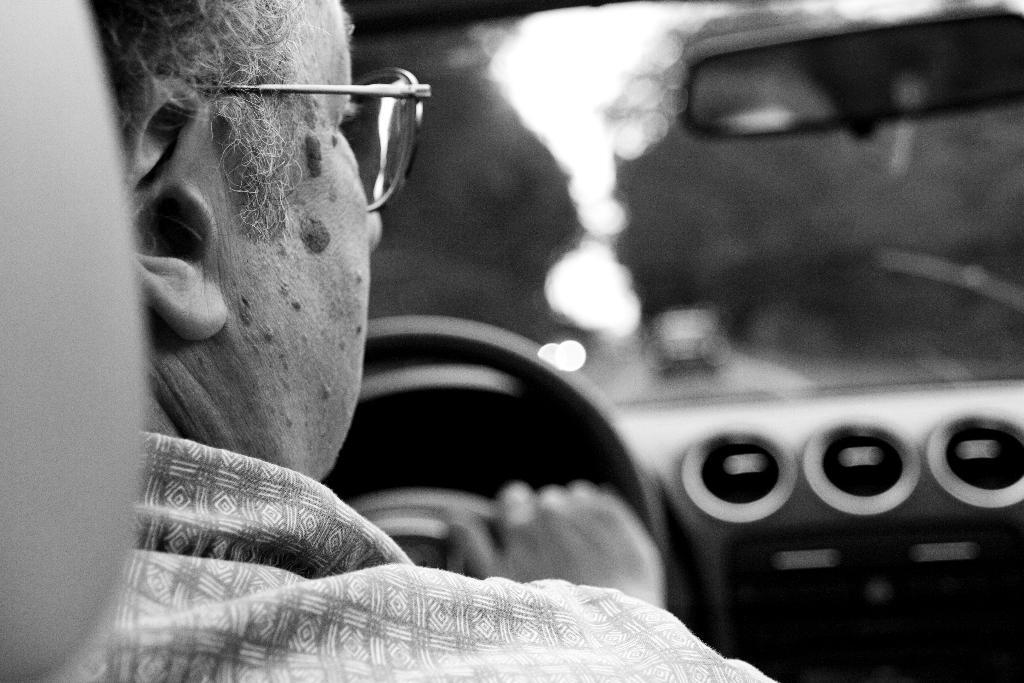What is the main subject of the image? There is a person in the image. What can be observed about the person's appearance? The person is wearing spectacles. What is the person doing in the image? The person is sitting on a seat and driving a vehicle. Where is the vehicle located? The vehicle is on a road. Can you describe the background of the image? The background of the image is blurred. What is the person's brother doing in the image? There is no mention of a brother in the image, so it cannot be determined what they might be doing. 